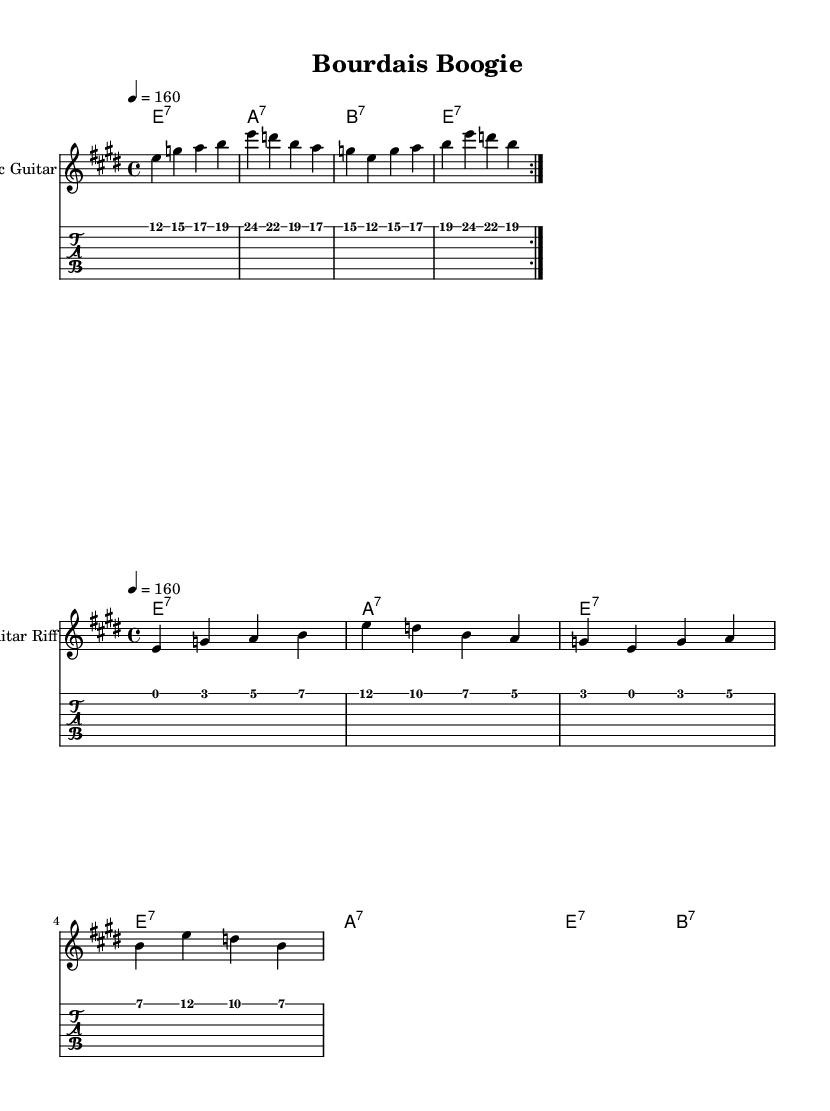What is the key signature of this music? The key signature is E major, which has four sharps (F#, C#, G#, D#). This can be identified at the beginning of the sheet music.
Answer: E major What is the time signature of the piece? The time signature is 4/4, indicating four beats per measure. This is shown at the start of the music.
Answer: 4/4 What is the tempo marking of this music? The tempo marking is 4 equals 160, indicating a fast tempo of 160 beats per minute. This is typically noted above the music staff.
Answer: 160 How many times is the melody repeated? The melody is repeated twice, as indicated by the "repeat volta" notation. This signifies that the section will be played two times in a row.
Answer: 2 What types of chords are predominantly used in this piece? The chords used are seventh chords, specifically E7, A7, and B7. This can be deduced from the chord names listed above the staff in the sheet music.
Answer: Seventh chords Which instrument is the primary melody instrument in this piece? The primary melody instrument is Electric Guitar, as noted in the staff under the instrument name.
Answer: Electric Guitar What is the structure of the guitar riff section? The guitar riff section consists of four measures with distinctive rhythmic patterns. Analyzing the measures shows a repeated structure with variations typical in blues.
Answer: Four measures 